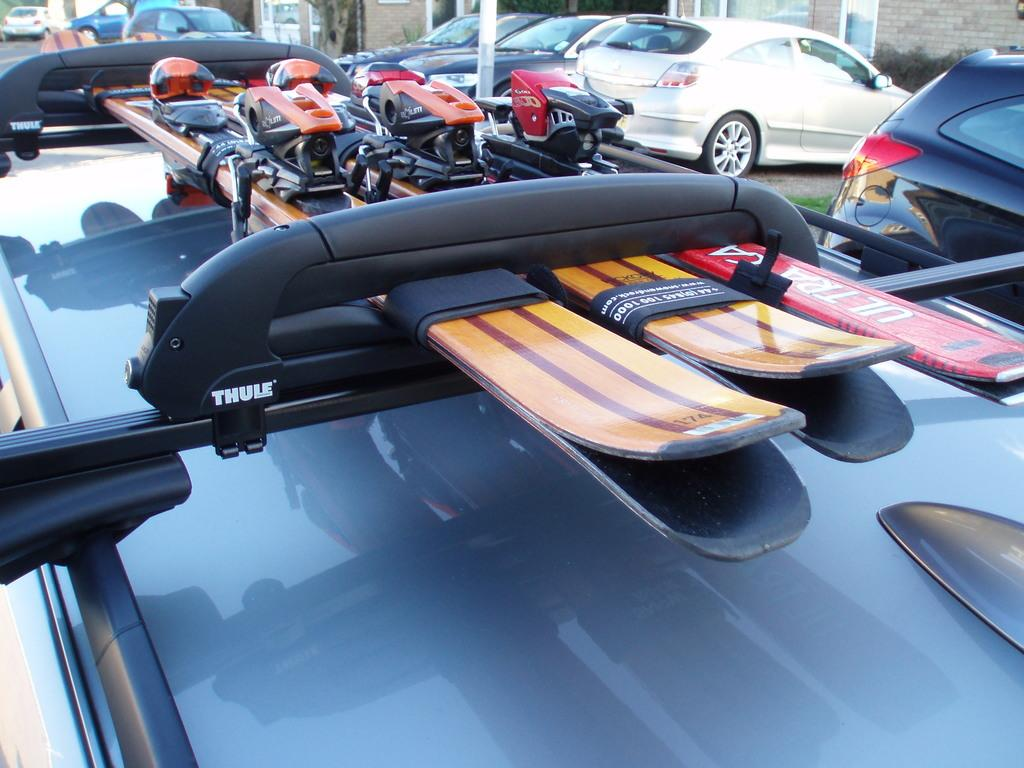What type of equipment is on the carrier of the car in the image? There are ski boards on the carrier of the car. What else can be seen in the image besides the car with ski boards? There are cars parked in the background and a wall of a house visible at the top of the image. What type of attention-grabbing bait is being used to attract fish in the image? There is no mention of fish or bait in the image; it features a car with ski boards on its carrier and parked cars in the background. 